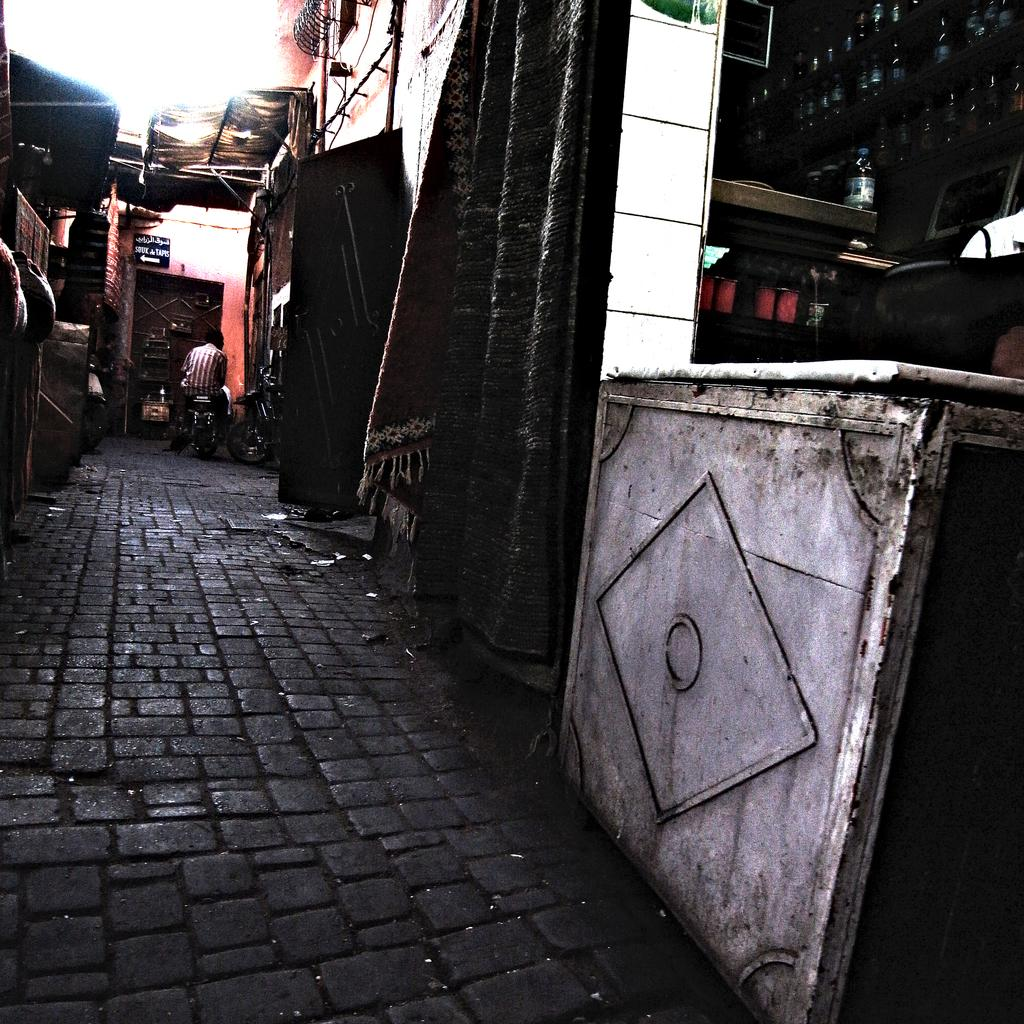What can be seen in the racks in the image? There are bottles in the racks in the image. What type of material is visible in the image? There is cloth visible in the image. What are the rods used for in the image? The rods are not explicitly described in the facts, so we cannot determine their purpose. What is the name board used for in the image? The name board is likely used for identification or labeling purposes. What is the background of the image made of? The wall in the image suggests that the background is made of a solid material, such as brick or concrete. What is the path used for in the image? The path is likely used for walking or driving on. What is the person sitting on in the image? The person is sitting on a motorbike in the image. Can you describe the unspecified objects in the image? The facts do not provide enough information to describe the unspecified objects in the image. How much wealth is displayed on the vessel in the image? There is no vessel or wealth present in the image. What type of crib is visible in the image? There is no crib present in the image. 